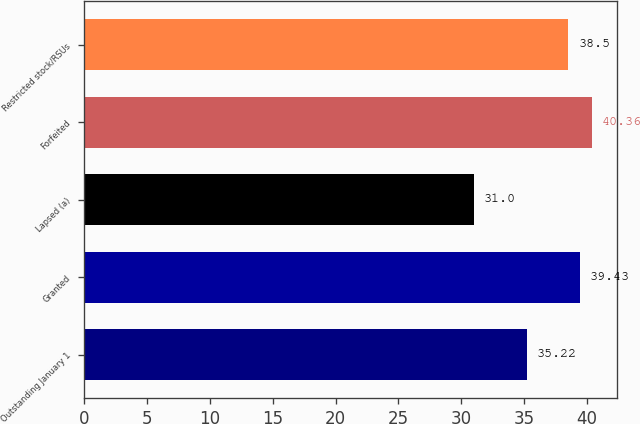Convert chart. <chart><loc_0><loc_0><loc_500><loc_500><bar_chart><fcel>Outstanding January 1<fcel>Granted<fcel>Lapsed (a)<fcel>Forfeited<fcel>Restricted stock/RSUs<nl><fcel>35.22<fcel>39.43<fcel>31<fcel>40.36<fcel>38.5<nl></chart> 